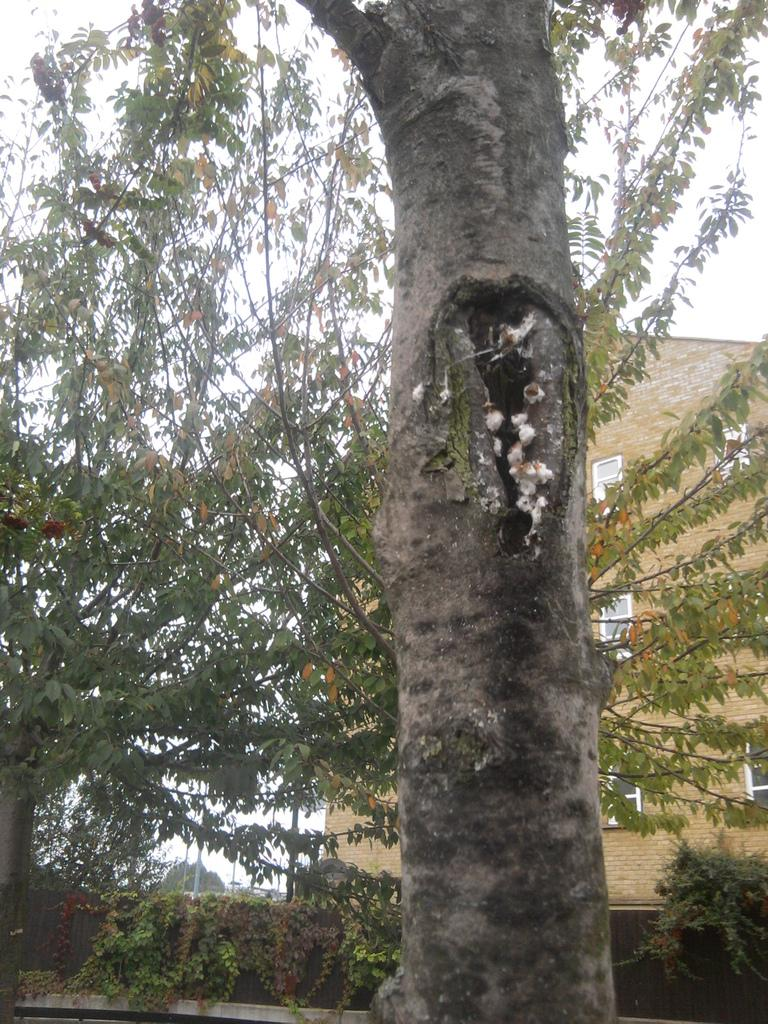What type of vegetation can be seen in the image? There are trees in the image. What type of structure is present in the image? There is a fence in the image. What type of man-made structures can be seen in the image? There are buildings in the image. What type of vertical structures are present in the image? There are poles in the image. What type of climbing plants can be seen in the image? There are creepers in the image. What part of a tree is visible in the image? There is a tree trunk in the image. What part of the natural environment is visible in the image? The sky is visible in the image. What type of attraction can be seen at the top of the tree in the image? There is no attraction present in the image, and the tree trunk is the only visible part of the tree. What type of yoke is used to support the creepers in the image? There is no yoke present in the image; the creepers are climbing the trees and structures on their own. 